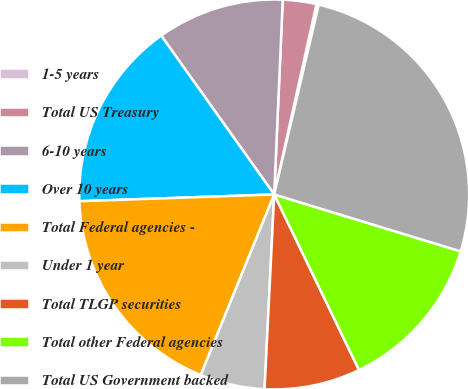Convert chart to OTSL. <chart><loc_0><loc_0><loc_500><loc_500><pie_chart><fcel>1-5 years<fcel>Total US Treasury<fcel>6-10 years<fcel>Over 10 years<fcel>Total Federal agencies -<fcel>Under 1 year<fcel>Total TLGP securities<fcel>Total other Federal agencies<fcel>Total US Government backed<nl><fcel>0.19%<fcel>2.78%<fcel>10.54%<fcel>15.71%<fcel>18.3%<fcel>5.36%<fcel>7.95%<fcel>13.12%<fcel>26.05%<nl></chart> 